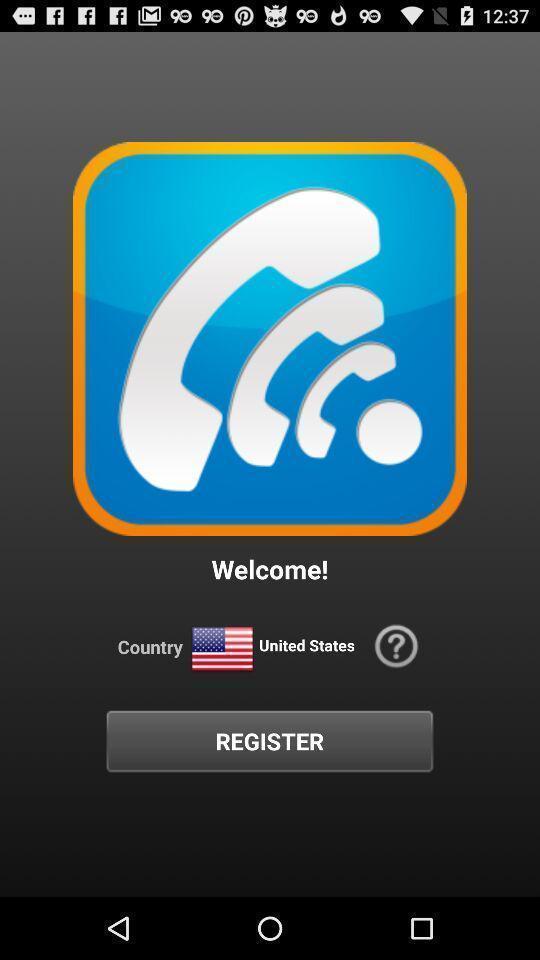Provide a detailed account of this screenshot. Welcome page. 